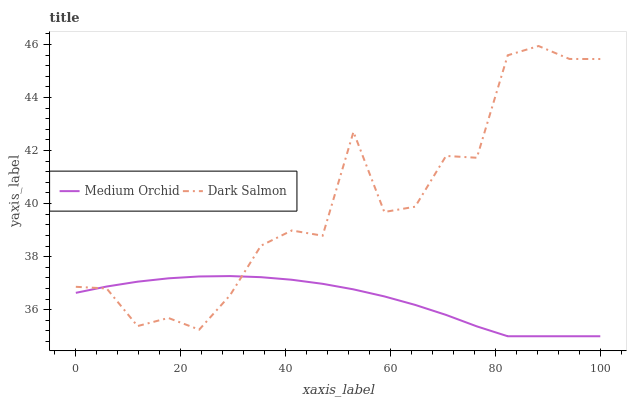Does Medium Orchid have the minimum area under the curve?
Answer yes or no. Yes. Does Dark Salmon have the maximum area under the curve?
Answer yes or no. Yes. Does Dark Salmon have the minimum area under the curve?
Answer yes or no. No. Is Medium Orchid the smoothest?
Answer yes or no. Yes. Is Dark Salmon the roughest?
Answer yes or no. Yes. Is Dark Salmon the smoothest?
Answer yes or no. No. Does Medium Orchid have the lowest value?
Answer yes or no. Yes. Does Dark Salmon have the lowest value?
Answer yes or no. No. Does Dark Salmon have the highest value?
Answer yes or no. Yes. Does Dark Salmon intersect Medium Orchid?
Answer yes or no. Yes. Is Dark Salmon less than Medium Orchid?
Answer yes or no. No. Is Dark Salmon greater than Medium Orchid?
Answer yes or no. No. 